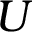Convert formula to latex. <formula><loc_0><loc_0><loc_500><loc_500>U</formula> 